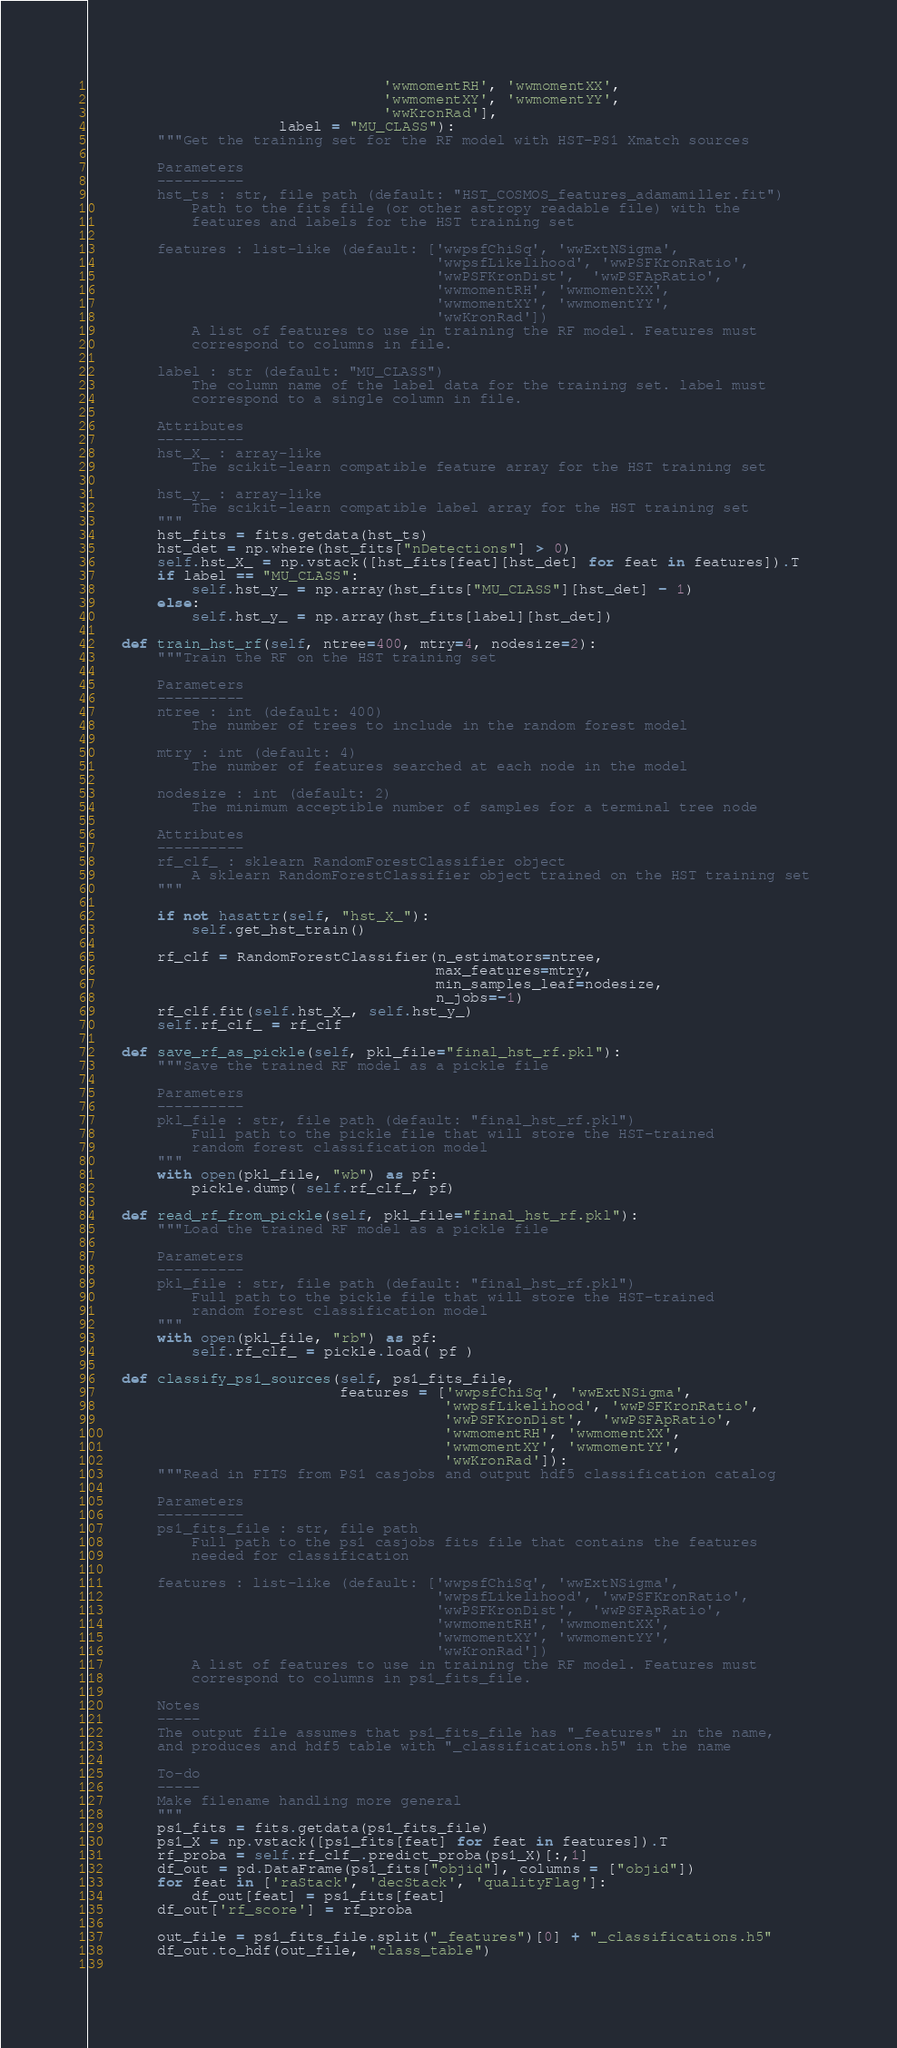Convert code to text. <code><loc_0><loc_0><loc_500><loc_500><_Python_>                                  'wwmomentRH', 'wwmomentXX', 
                                  'wwmomentXY', 'wwmomentYY', 
                                  'wwKronRad'],
                      label = "MU_CLASS"):
        """Get the training set for the RF model with HST-PS1 Xmatch sources 
        
        Parameters
        ----------
        hst_ts : str, file path (default: "HST_COSMOS_features_adamamiller.fit")
            Path to the fits file (or other astropy readable file) with the 
            features and labels for the HST training set
        
        features : list-like (default: ['wwpsfChiSq', 'wwExtNSigma', 
                                        'wwpsfLikelihood', 'wwPSFKronRatio', 
                                        'wwPSFKronDist',  'wwPSFApRatio', 
                                        'wwmomentRH', 'wwmomentXX', 
                                        'wwmomentXY', 'wwmomentYY', 
                                        'wwKronRad'])
            A list of features to use in training the RF model. Features must 
            correspond to columns in file.
        
        label : str (default: "MU_CLASS")
            The column name of the label data for the training set. label must 
            correspond to a single column in file.
        
        Attributes
        ----------
        hst_X_ : array-like
            The scikit-learn compatible feature array for the HST training set
        
        hst_y_ : array-like
            The scikit-learn compatible label array for the HST training set        
        """
        hst_fits = fits.getdata(hst_ts)
        hst_det = np.where(hst_fits["nDetections"] > 0)
        self.hst_X_ = np.vstack([hst_fits[feat][hst_det] for feat in features]).T
        if label == "MU_CLASS":
            self.hst_y_ = np.array(hst_fits["MU_CLASS"][hst_det] - 1)
        else:
            self.hst_y_ = np.array(hst_fits[label][hst_det])
    
    def train_hst_rf(self, ntree=400, mtry=4, nodesize=2):
        """Train the RF on the HST training set
        
        Parameters
        ----------
        ntree : int (default: 400)
            The number of trees to include in the random forest model
        
        mtry : int (default: 4)
            The number of features searched at each node in the model
        
        nodesize : int (default: 2)
            The minimum acceptible number of samples for a terminal tree node
        
        Attributes
        ----------
        rf_clf_ : sklearn RandomForestClassifier object
            A sklearn RandomForestClassifier object trained on the HST training set 
        """
        
        if not hasattr(self, "hst_X_"):
            self.get_hst_train()
        
        rf_clf = RandomForestClassifier(n_estimators=ntree, 
                                        max_features=mtry,
                                        min_samples_leaf=nodesize,
                                        n_jobs=-1)
        rf_clf.fit(self.hst_X_, self.hst_y_)
        self.rf_clf_ = rf_clf
    
    def save_rf_as_pickle(self, pkl_file="final_hst_rf.pkl"):
        """Save the trained RF model as a pickle file
        
        Parameters
        ----------
        pkl_file : str, file path (default: "final_hst_rf.pkl")
            Full path to the pickle file that will store the HST-trained 
            random forest classification model
        """
        with open(pkl_file, "wb") as pf:
            pickle.dump( self.rf_clf_, pf)
    
    def read_rf_from_pickle(self, pkl_file="final_hst_rf.pkl"):
        """Load the trained RF model as a pickle file
        
        Parameters
        ----------
        pkl_file : str, file path (default: "final_hst_rf.pkl")
            Full path to the pickle file that will store the HST-trained 
            random forest classification model       
        """
        with open(pkl_file, "rb") as pf:
            self.rf_clf_ = pickle.load( pf )
    
    def classify_ps1_sources(self, ps1_fits_file,
                             features = ['wwpsfChiSq', 'wwExtNSigma', 
                                         'wwpsfLikelihood', 'wwPSFKronRatio', 
                                         'wwPSFKronDist',  'wwPSFApRatio', 
                                         'wwmomentRH', 'wwmomentXX', 
                                         'wwmomentXY', 'wwmomentYY', 
                                         'wwKronRad']):
        """Read in FITS from PS1 casjobs and output hdf5 classification catalog
        
        Parameters
        ----------
        ps1_fits_file : str, file path
            Full path to the ps1 casjobs fits file that contains the features 
            needed for classification
        
        features : list-like (default: ['wwpsfChiSq', 'wwExtNSigma', 
                                        'wwpsfLikelihood', 'wwPSFKronRatio', 
                                        'wwPSFKronDist',  'wwPSFApRatio', 
                                        'wwmomentRH', 'wwmomentXX', 
                                        'wwmomentXY', 'wwmomentYY', 
                                        'wwKronRad'])
            A list of features to use in training the RF model. Features must 
            correspond to columns in ps1_fits_file.
        
        Notes
        -----
        The output file assumes that ps1_fits_file has "_features" in the name, 
        and produces and hdf5 table with "_classifications.h5" in the name
        
        To-do
        -----
        Make filename handling more general
        """
        ps1_fits = fits.getdata(ps1_fits_file)
        ps1_X = np.vstack([ps1_fits[feat] for feat in features]).T
        rf_proba = self.rf_clf_.predict_proba(ps1_X)[:,1]
        df_out = pd.DataFrame(ps1_fits["objid"], columns = ["objid"])
        for feat in ['raStack', 'decStack', 'qualityFlag']:
            df_out[feat] = ps1_fits[feat]
        df_out['rf_score'] = rf_proba
                
        out_file = ps1_fits_file.split("_features")[0] + "_classifications.h5"
        df_out.to_hdf(out_file, "class_table")
        </code> 